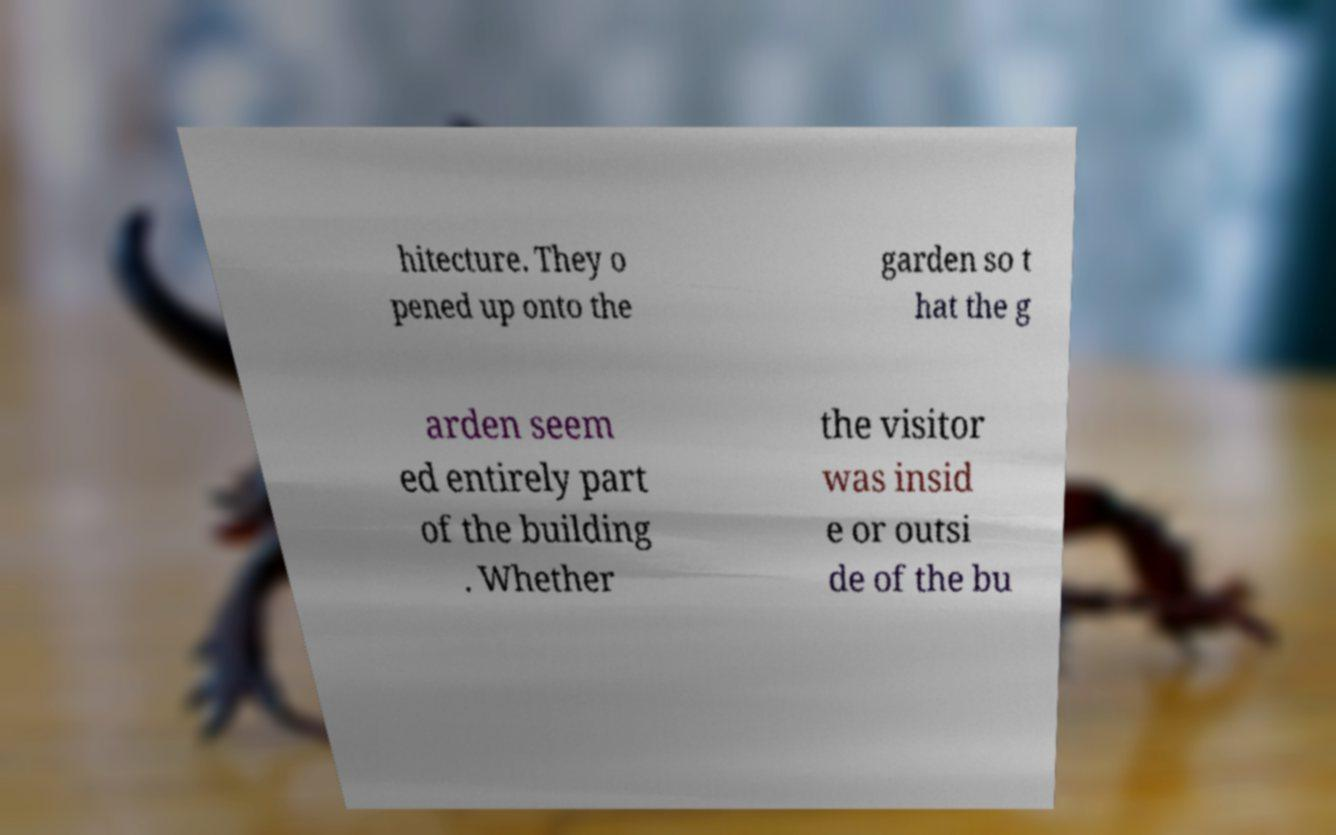Could you assist in decoding the text presented in this image and type it out clearly? hitecture. They o pened up onto the garden so t hat the g arden seem ed entirely part of the building . Whether the visitor was insid e or outsi de of the bu 